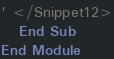<code> <loc_0><loc_0><loc_500><loc_500><_VisualBasic_>' </Snippet12>
   End Sub
End Module

</code> 